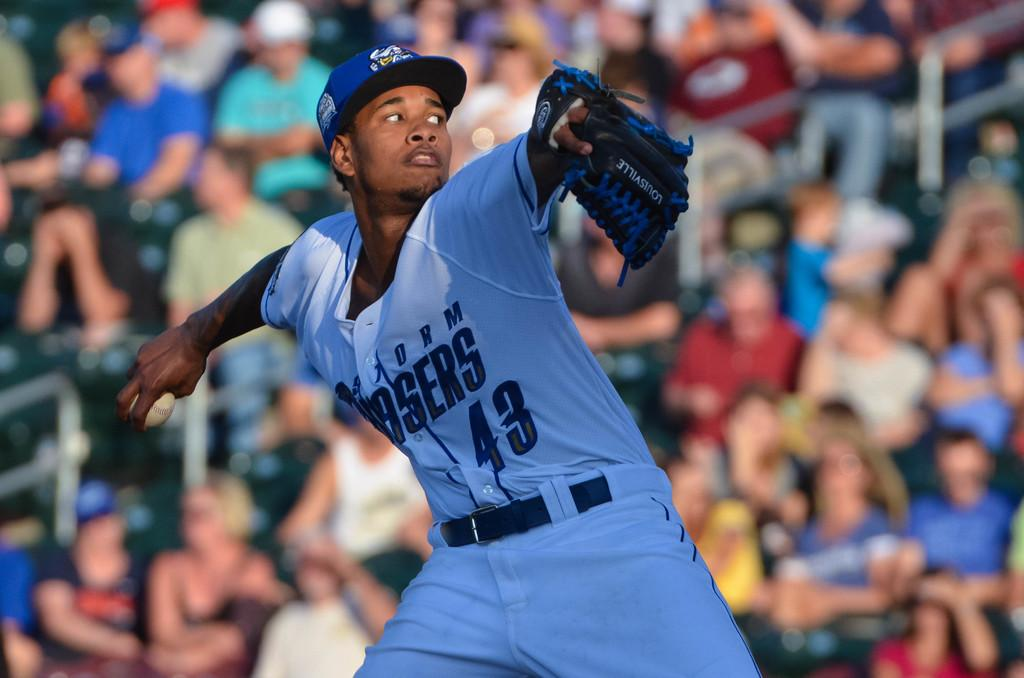<image>
Create a compact narrative representing the image presented. The guy throwing the baseball wears the number 43 on his jersey. 